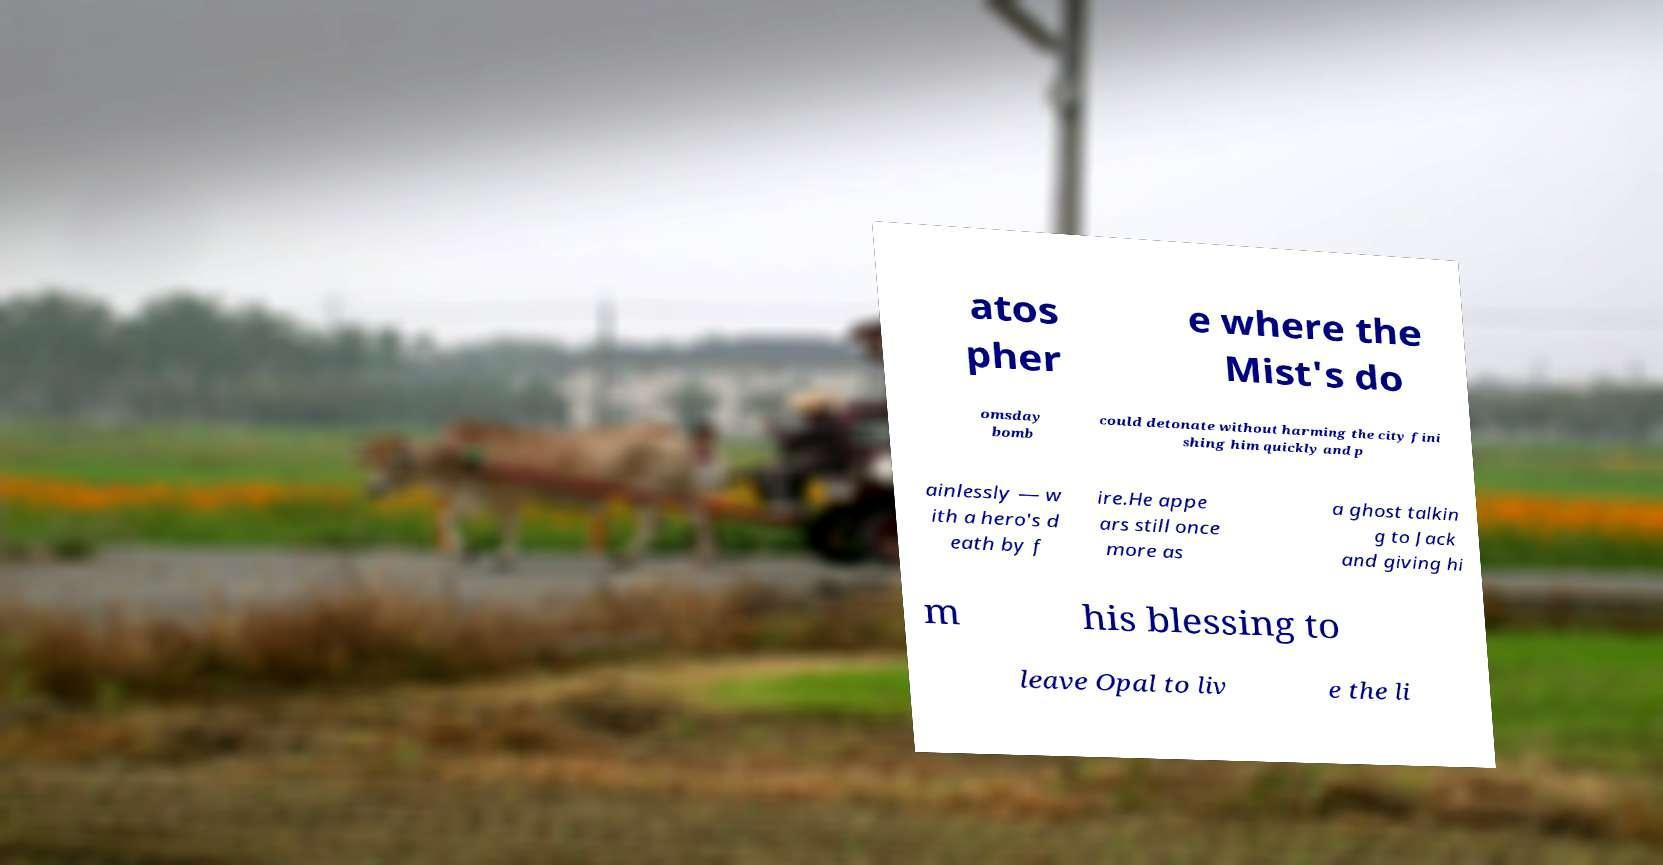What messages or text are displayed in this image? I need them in a readable, typed format. atos pher e where the Mist's do omsday bomb could detonate without harming the city fini shing him quickly and p ainlessly — w ith a hero's d eath by f ire.He appe ars still once more as a ghost talkin g to Jack and giving hi m his blessing to leave Opal to liv e the li 